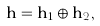Convert formula to latex. <formula><loc_0><loc_0><loc_500><loc_500>\mathbf h = { \mathbf h } _ { 1 } \oplus { \mathbf h } _ { 2 } ,</formula> 